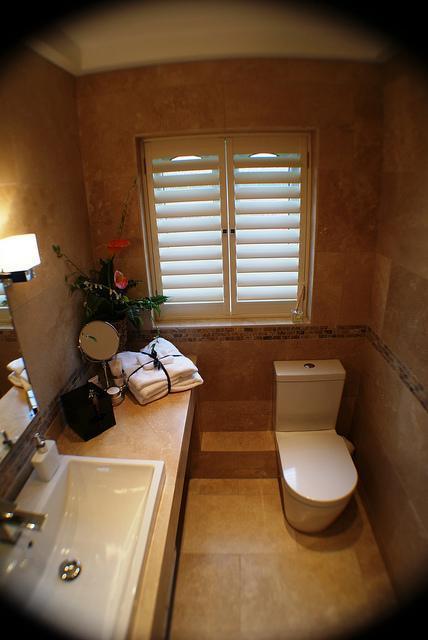How many toilets are there?
Give a very brief answer. 1. How many of these buses are big red tall boys with two floors nice??
Give a very brief answer. 0. 